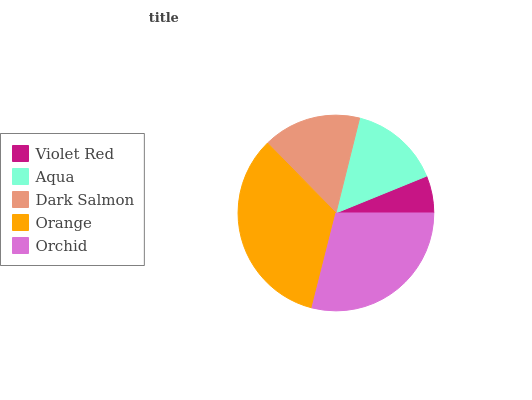Is Violet Red the minimum?
Answer yes or no. Yes. Is Orange the maximum?
Answer yes or no. Yes. Is Aqua the minimum?
Answer yes or no. No. Is Aqua the maximum?
Answer yes or no. No. Is Aqua greater than Violet Red?
Answer yes or no. Yes. Is Violet Red less than Aqua?
Answer yes or no. Yes. Is Violet Red greater than Aqua?
Answer yes or no. No. Is Aqua less than Violet Red?
Answer yes or no. No. Is Dark Salmon the high median?
Answer yes or no. Yes. Is Dark Salmon the low median?
Answer yes or no. Yes. Is Violet Red the high median?
Answer yes or no. No. Is Aqua the low median?
Answer yes or no. No. 